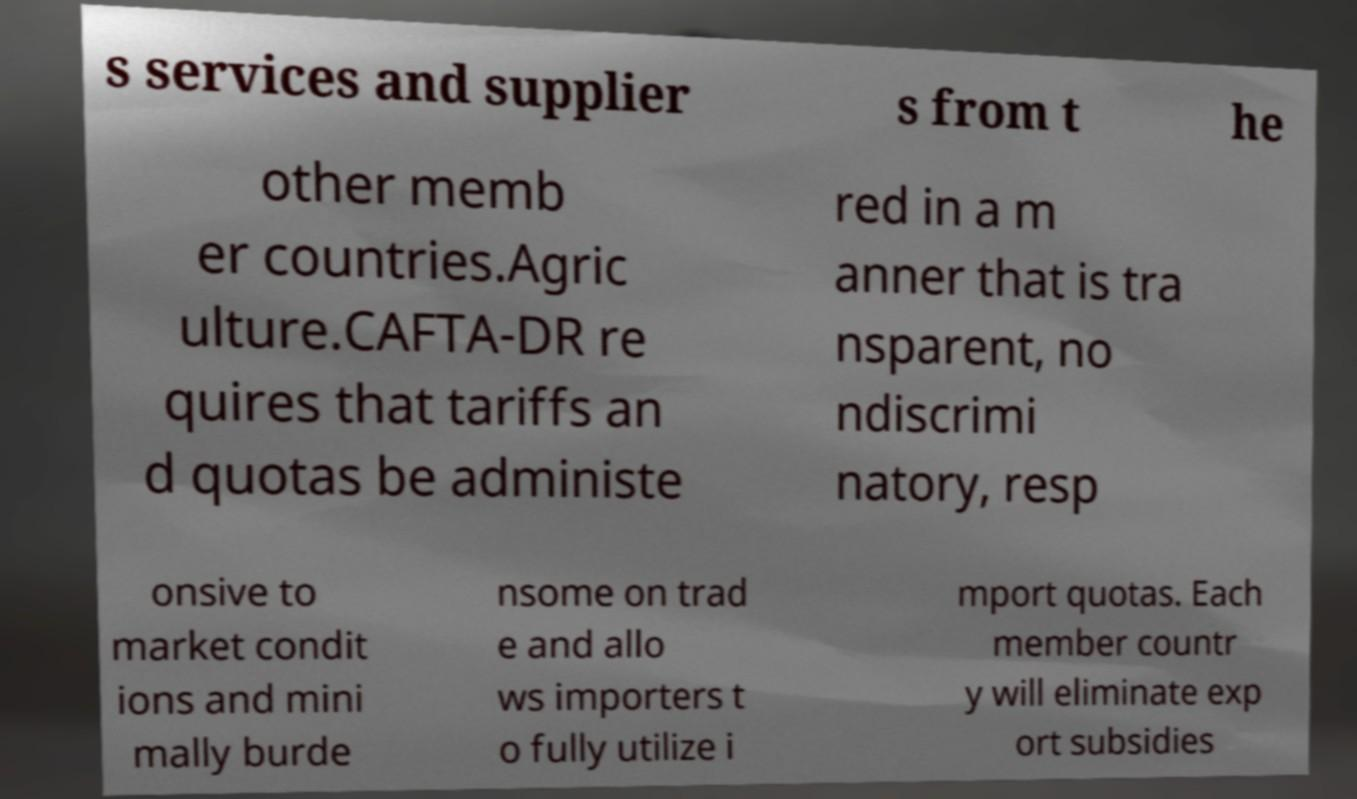There's text embedded in this image that I need extracted. Can you transcribe it verbatim? s services and supplier s from t he other memb er countries.Agric ulture.CAFTA-DR re quires that tariffs an d quotas be administe red in a m anner that is tra nsparent, no ndiscrimi natory, resp onsive to market condit ions and mini mally burde nsome on trad e and allo ws importers t o fully utilize i mport quotas. Each member countr y will eliminate exp ort subsidies 